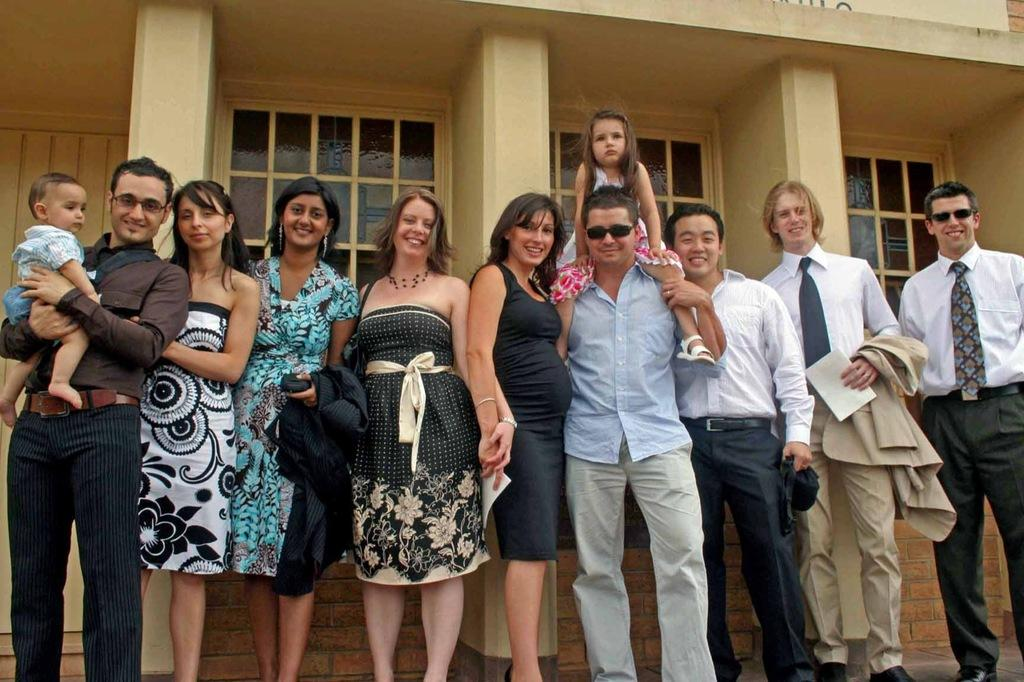What are the people in the image doing? The people in the image are standing and smiling. Where are the people standing in the image? The people are standing on the floor. What can be seen in the background of the image? There is a building in the background of the image. What type of windows does the building have? The building has glass windows. What type of root can be seen growing from the people's feet in the image? There is no root growing from the people's feet in the image; they are standing on the floor. 